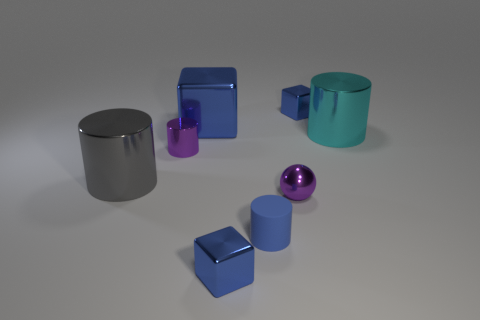Add 1 tiny metallic cubes. How many objects exist? 9 Subtract all blocks. How many objects are left? 5 Subtract all large cyan metal objects. Subtract all small blue metallic spheres. How many objects are left? 7 Add 4 tiny blocks. How many tiny blocks are left? 6 Add 7 tiny purple metallic cylinders. How many tiny purple metallic cylinders exist? 8 Subtract 0 yellow cylinders. How many objects are left? 8 